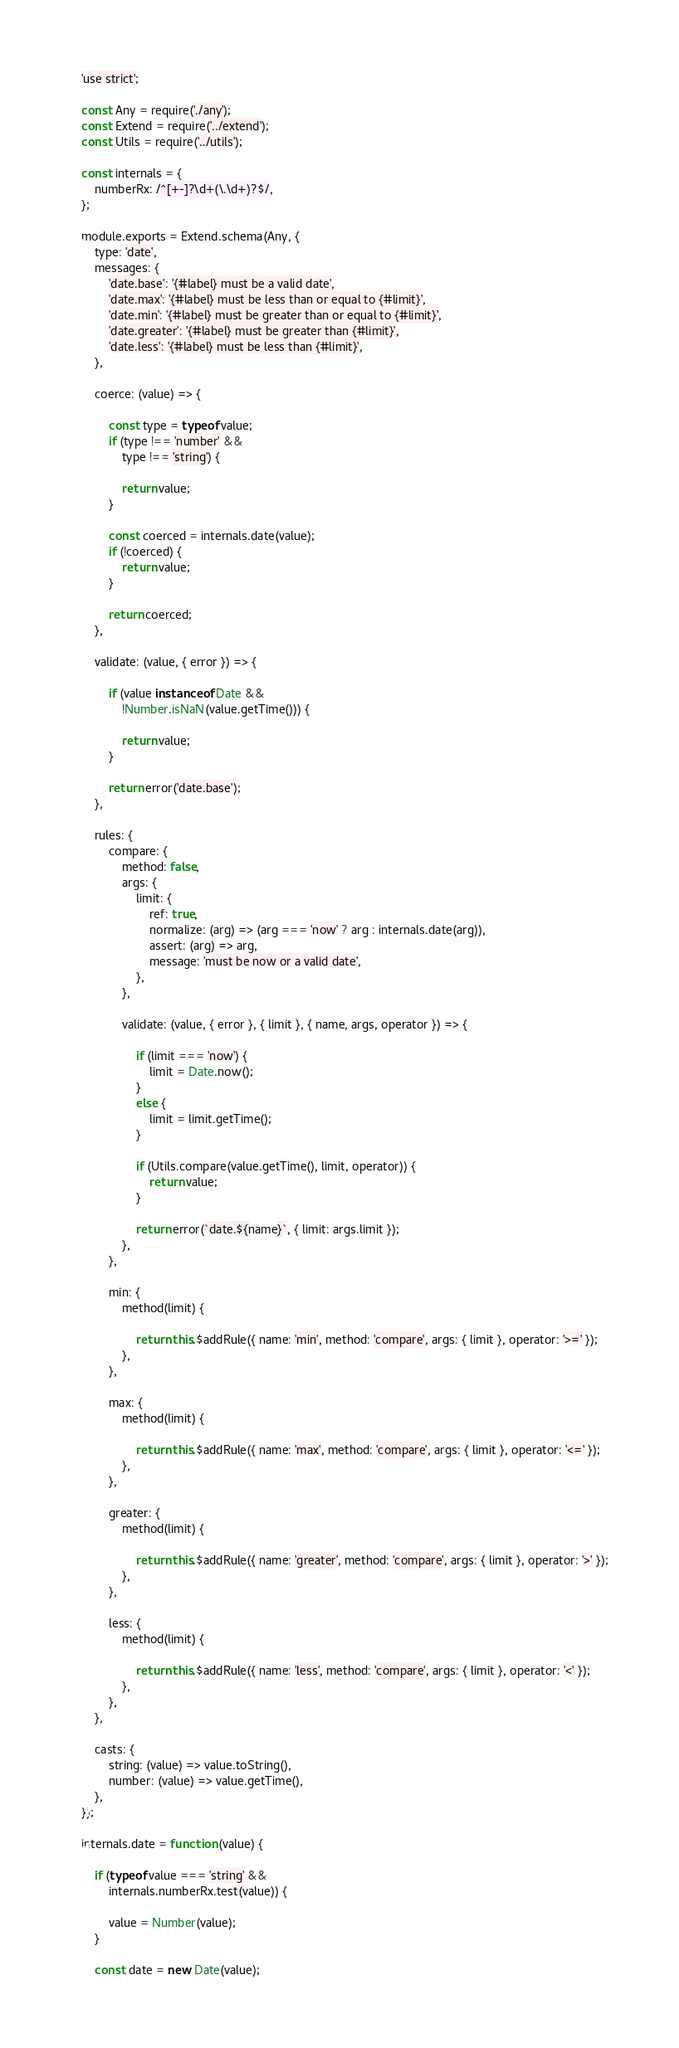<code> <loc_0><loc_0><loc_500><loc_500><_JavaScript_>'use strict';

const Any = require('./any');
const Extend = require('../extend');
const Utils = require('../utils');

const internals = {
    numberRx: /^[+-]?\d+(\.\d+)?$/,
};

module.exports = Extend.schema(Any, {
    type: 'date',
    messages: {
        'date.base': '{#label} must be a valid date',
        'date.max': '{#label} must be less than or equal to {#limit}',
        'date.min': '{#label} must be greater than or equal to {#limit}',
        'date.greater': '{#label} must be greater than {#limit}',
        'date.less': '{#label} must be less than {#limit}',
    },

    coerce: (value) => {

        const type = typeof value;
        if (type !== 'number' &&
            type !== 'string') {

            return value;
        }

        const coerced = internals.date(value);
        if (!coerced) {
            return value;
        }

        return coerced;
    },

    validate: (value, { error }) => {

        if (value instanceof Date &&
            !Number.isNaN(value.getTime())) {

            return value;
        }

        return error('date.base');
    },

    rules: {
        compare: {
            method: false,
            args: {
                limit: {
                    ref: true,
                    normalize: (arg) => (arg === 'now' ? arg : internals.date(arg)),
                    assert: (arg) => arg,
                    message: 'must be now or a valid date',
                },
            },

            validate: (value, { error }, { limit }, { name, args, operator }) => {

                if (limit === 'now') {
                    limit = Date.now();
                }
                else {
                    limit = limit.getTime();
                }

                if (Utils.compare(value.getTime(), limit, operator)) {
                    return value;
                }

                return error(`date.${name}`, { limit: args.limit });
            },
        },

        min: {
            method(limit) {

                return this.$addRule({ name: 'min', method: 'compare', args: { limit }, operator: '>=' });
            },
        },

        max: {
            method(limit) {

                return this.$addRule({ name: 'max', method: 'compare', args: { limit }, operator: '<=' });
            },
        },

        greater: {
            method(limit) {

                return this.$addRule({ name: 'greater', method: 'compare', args: { limit }, operator: '>' });
            },
        },

        less: {
            method(limit) {

                return this.$addRule({ name: 'less', method: 'compare', args: { limit }, operator: '<' });
            },
        },
    },

    casts: {
        string: (value) => value.toString(),
        number: (value) => value.getTime(),
    },
});

internals.date = function (value) {

    if (typeof value === 'string' &&
        internals.numberRx.test(value)) {

        value = Number(value);
    }

    const date = new Date(value);</code> 